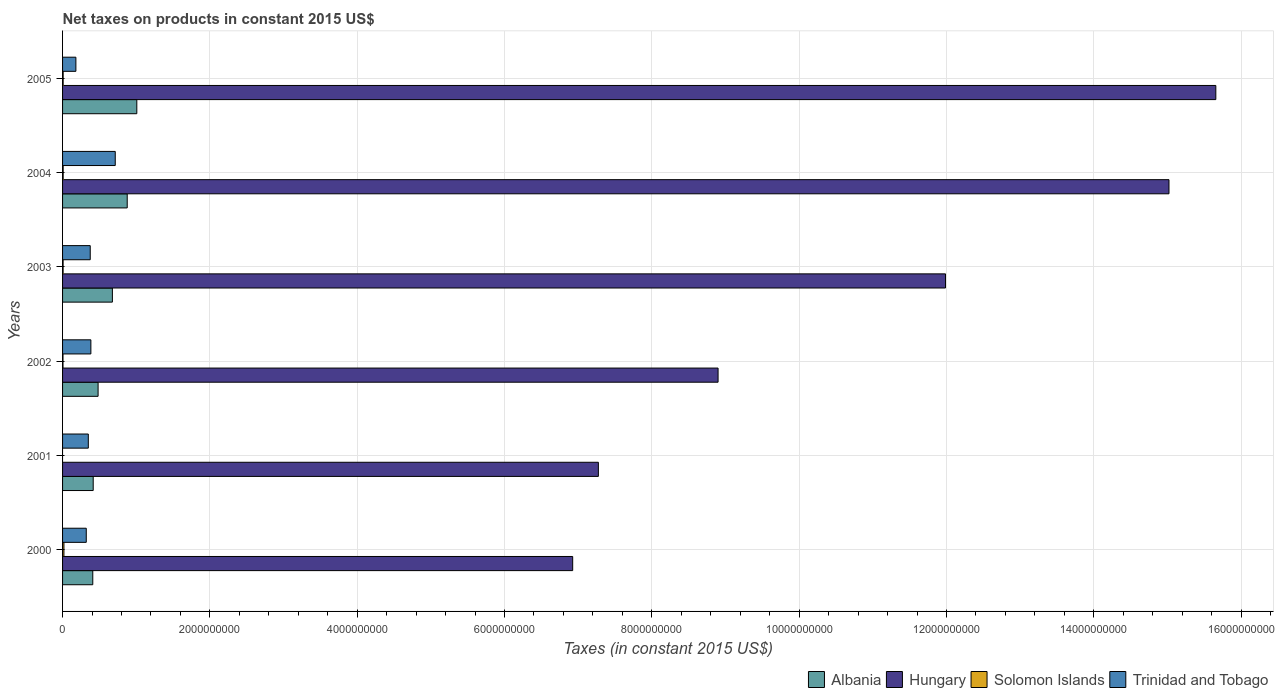Are the number of bars per tick equal to the number of legend labels?
Offer a terse response. No. Are the number of bars on each tick of the Y-axis equal?
Your answer should be very brief. No. How many bars are there on the 2nd tick from the top?
Provide a succinct answer. 4. What is the label of the 2nd group of bars from the top?
Provide a short and direct response. 2004. In how many cases, is the number of bars for a given year not equal to the number of legend labels?
Provide a succinct answer. 1. What is the net taxes on products in Hungary in 2004?
Your response must be concise. 1.50e+1. Across all years, what is the maximum net taxes on products in Hungary?
Your answer should be compact. 1.57e+1. Across all years, what is the minimum net taxes on products in Albania?
Offer a terse response. 4.10e+08. What is the total net taxes on products in Solomon Islands in the graph?
Your answer should be very brief. 4.81e+07. What is the difference between the net taxes on products in Solomon Islands in 2000 and that in 2003?
Your answer should be very brief. 1.11e+07. What is the difference between the net taxes on products in Solomon Islands in 2001 and the net taxes on products in Trinidad and Tobago in 2002?
Make the answer very short. -3.84e+08. What is the average net taxes on products in Trinidad and Tobago per year?
Keep it short and to the point. 3.88e+08. In the year 2004, what is the difference between the net taxes on products in Hungary and net taxes on products in Solomon Islands?
Provide a short and direct response. 1.50e+1. What is the ratio of the net taxes on products in Hungary in 2000 to that in 2001?
Keep it short and to the point. 0.95. Is the net taxes on products in Albania in 2000 less than that in 2002?
Provide a succinct answer. Yes. What is the difference between the highest and the second highest net taxes on products in Solomon Islands?
Keep it short and to the point. 1.04e+07. What is the difference between the highest and the lowest net taxes on products in Trinidad and Tobago?
Your response must be concise. 5.34e+08. In how many years, is the net taxes on products in Solomon Islands greater than the average net taxes on products in Solomon Islands taken over all years?
Make the answer very short. 2. Is it the case that in every year, the sum of the net taxes on products in Albania and net taxes on products in Trinidad and Tobago is greater than the sum of net taxes on products in Solomon Islands and net taxes on products in Hungary?
Keep it short and to the point. Yes. How many bars are there?
Give a very brief answer. 23. What is the difference between two consecutive major ticks on the X-axis?
Your response must be concise. 2.00e+09. Are the values on the major ticks of X-axis written in scientific E-notation?
Give a very brief answer. No. Does the graph contain any zero values?
Provide a succinct answer. Yes. Does the graph contain grids?
Offer a terse response. Yes. How are the legend labels stacked?
Your response must be concise. Horizontal. What is the title of the graph?
Your response must be concise. Net taxes on products in constant 2015 US$. Does "France" appear as one of the legend labels in the graph?
Provide a succinct answer. No. What is the label or title of the X-axis?
Make the answer very short. Taxes (in constant 2015 US$). What is the Taxes (in constant 2015 US$) of Albania in 2000?
Provide a succinct answer. 4.10e+08. What is the Taxes (in constant 2015 US$) of Hungary in 2000?
Give a very brief answer. 6.93e+09. What is the Taxes (in constant 2015 US$) of Solomon Islands in 2000?
Provide a short and direct response. 1.86e+07. What is the Taxes (in constant 2015 US$) in Trinidad and Tobago in 2000?
Give a very brief answer. 3.22e+08. What is the Taxes (in constant 2015 US$) in Albania in 2001?
Ensure brevity in your answer.  4.16e+08. What is the Taxes (in constant 2015 US$) of Hungary in 2001?
Provide a short and direct response. 7.27e+09. What is the Taxes (in constant 2015 US$) in Solomon Islands in 2001?
Give a very brief answer. 0. What is the Taxes (in constant 2015 US$) in Trinidad and Tobago in 2001?
Make the answer very short. 3.50e+08. What is the Taxes (in constant 2015 US$) of Albania in 2002?
Offer a terse response. 4.82e+08. What is the Taxes (in constant 2015 US$) in Hungary in 2002?
Offer a terse response. 8.90e+09. What is the Taxes (in constant 2015 US$) of Solomon Islands in 2002?
Your answer should be compact. 5.98e+06. What is the Taxes (in constant 2015 US$) in Trinidad and Tobago in 2002?
Your answer should be very brief. 3.84e+08. What is the Taxes (in constant 2015 US$) of Albania in 2003?
Offer a very short reply. 6.76e+08. What is the Taxes (in constant 2015 US$) of Hungary in 2003?
Keep it short and to the point. 1.20e+1. What is the Taxes (in constant 2015 US$) of Solomon Islands in 2003?
Keep it short and to the point. 7.43e+06. What is the Taxes (in constant 2015 US$) in Trinidad and Tobago in 2003?
Your answer should be compact. 3.76e+08. What is the Taxes (in constant 2015 US$) of Albania in 2004?
Provide a short and direct response. 8.78e+08. What is the Taxes (in constant 2015 US$) of Hungary in 2004?
Ensure brevity in your answer.  1.50e+1. What is the Taxes (in constant 2015 US$) of Solomon Islands in 2004?
Your answer should be very brief. 8.16e+06. What is the Taxes (in constant 2015 US$) of Trinidad and Tobago in 2004?
Ensure brevity in your answer.  7.15e+08. What is the Taxes (in constant 2015 US$) in Albania in 2005?
Ensure brevity in your answer.  1.01e+09. What is the Taxes (in constant 2015 US$) in Hungary in 2005?
Your response must be concise. 1.57e+1. What is the Taxes (in constant 2015 US$) in Solomon Islands in 2005?
Offer a terse response. 8.01e+06. What is the Taxes (in constant 2015 US$) of Trinidad and Tobago in 2005?
Make the answer very short. 1.81e+08. Across all years, what is the maximum Taxes (in constant 2015 US$) in Albania?
Your answer should be compact. 1.01e+09. Across all years, what is the maximum Taxes (in constant 2015 US$) of Hungary?
Your answer should be compact. 1.57e+1. Across all years, what is the maximum Taxes (in constant 2015 US$) of Solomon Islands?
Ensure brevity in your answer.  1.86e+07. Across all years, what is the maximum Taxes (in constant 2015 US$) of Trinidad and Tobago?
Offer a very short reply. 7.15e+08. Across all years, what is the minimum Taxes (in constant 2015 US$) of Albania?
Provide a short and direct response. 4.10e+08. Across all years, what is the minimum Taxes (in constant 2015 US$) of Hungary?
Give a very brief answer. 6.93e+09. Across all years, what is the minimum Taxes (in constant 2015 US$) of Trinidad and Tobago?
Make the answer very short. 1.81e+08. What is the total Taxes (in constant 2015 US$) in Albania in the graph?
Make the answer very short. 3.87e+09. What is the total Taxes (in constant 2015 US$) of Hungary in the graph?
Offer a very short reply. 6.58e+1. What is the total Taxes (in constant 2015 US$) of Solomon Islands in the graph?
Offer a terse response. 4.81e+07. What is the total Taxes (in constant 2015 US$) of Trinidad and Tobago in the graph?
Offer a very short reply. 2.33e+09. What is the difference between the Taxes (in constant 2015 US$) in Albania in 2000 and that in 2001?
Offer a terse response. -5.75e+06. What is the difference between the Taxes (in constant 2015 US$) of Hungary in 2000 and that in 2001?
Provide a succinct answer. -3.49e+08. What is the difference between the Taxes (in constant 2015 US$) of Trinidad and Tobago in 2000 and that in 2001?
Your answer should be compact. -2.77e+07. What is the difference between the Taxes (in constant 2015 US$) of Albania in 2000 and that in 2002?
Make the answer very short. -7.21e+07. What is the difference between the Taxes (in constant 2015 US$) in Hungary in 2000 and that in 2002?
Your answer should be compact. -1.97e+09. What is the difference between the Taxes (in constant 2015 US$) of Solomon Islands in 2000 and that in 2002?
Provide a succinct answer. 1.26e+07. What is the difference between the Taxes (in constant 2015 US$) of Trinidad and Tobago in 2000 and that in 2002?
Ensure brevity in your answer.  -6.24e+07. What is the difference between the Taxes (in constant 2015 US$) of Albania in 2000 and that in 2003?
Keep it short and to the point. -2.66e+08. What is the difference between the Taxes (in constant 2015 US$) in Hungary in 2000 and that in 2003?
Make the answer very short. -5.06e+09. What is the difference between the Taxes (in constant 2015 US$) of Solomon Islands in 2000 and that in 2003?
Offer a terse response. 1.11e+07. What is the difference between the Taxes (in constant 2015 US$) in Trinidad and Tobago in 2000 and that in 2003?
Provide a succinct answer. -5.38e+07. What is the difference between the Taxes (in constant 2015 US$) in Albania in 2000 and that in 2004?
Give a very brief answer. -4.68e+08. What is the difference between the Taxes (in constant 2015 US$) in Hungary in 2000 and that in 2004?
Your answer should be very brief. -8.10e+09. What is the difference between the Taxes (in constant 2015 US$) of Solomon Islands in 2000 and that in 2004?
Offer a very short reply. 1.04e+07. What is the difference between the Taxes (in constant 2015 US$) in Trinidad and Tobago in 2000 and that in 2004?
Offer a terse response. -3.93e+08. What is the difference between the Taxes (in constant 2015 US$) in Albania in 2000 and that in 2005?
Give a very brief answer. -5.98e+08. What is the difference between the Taxes (in constant 2015 US$) in Hungary in 2000 and that in 2005?
Your answer should be compact. -8.73e+09. What is the difference between the Taxes (in constant 2015 US$) of Solomon Islands in 2000 and that in 2005?
Provide a succinct answer. 1.05e+07. What is the difference between the Taxes (in constant 2015 US$) of Trinidad and Tobago in 2000 and that in 2005?
Provide a short and direct response. 1.41e+08. What is the difference between the Taxes (in constant 2015 US$) in Albania in 2001 and that in 2002?
Your answer should be very brief. -6.63e+07. What is the difference between the Taxes (in constant 2015 US$) of Hungary in 2001 and that in 2002?
Make the answer very short. -1.63e+09. What is the difference between the Taxes (in constant 2015 US$) of Trinidad and Tobago in 2001 and that in 2002?
Your answer should be very brief. -3.47e+07. What is the difference between the Taxes (in constant 2015 US$) of Albania in 2001 and that in 2003?
Your answer should be compact. -2.60e+08. What is the difference between the Taxes (in constant 2015 US$) of Hungary in 2001 and that in 2003?
Make the answer very short. -4.71e+09. What is the difference between the Taxes (in constant 2015 US$) of Trinidad and Tobago in 2001 and that in 2003?
Provide a succinct answer. -2.60e+07. What is the difference between the Taxes (in constant 2015 US$) of Albania in 2001 and that in 2004?
Your answer should be compact. -4.62e+08. What is the difference between the Taxes (in constant 2015 US$) in Hungary in 2001 and that in 2004?
Provide a short and direct response. -7.75e+09. What is the difference between the Taxes (in constant 2015 US$) in Trinidad and Tobago in 2001 and that in 2004?
Your response must be concise. -3.66e+08. What is the difference between the Taxes (in constant 2015 US$) of Albania in 2001 and that in 2005?
Your answer should be very brief. -5.92e+08. What is the difference between the Taxes (in constant 2015 US$) of Hungary in 2001 and that in 2005?
Provide a short and direct response. -8.38e+09. What is the difference between the Taxes (in constant 2015 US$) in Trinidad and Tobago in 2001 and that in 2005?
Your answer should be compact. 1.69e+08. What is the difference between the Taxes (in constant 2015 US$) of Albania in 2002 and that in 2003?
Give a very brief answer. -1.94e+08. What is the difference between the Taxes (in constant 2015 US$) of Hungary in 2002 and that in 2003?
Your answer should be compact. -3.09e+09. What is the difference between the Taxes (in constant 2015 US$) in Solomon Islands in 2002 and that in 2003?
Provide a succinct answer. -1.46e+06. What is the difference between the Taxes (in constant 2015 US$) in Trinidad and Tobago in 2002 and that in 2003?
Offer a very short reply. 8.65e+06. What is the difference between the Taxes (in constant 2015 US$) of Albania in 2002 and that in 2004?
Offer a terse response. -3.95e+08. What is the difference between the Taxes (in constant 2015 US$) of Hungary in 2002 and that in 2004?
Make the answer very short. -6.12e+09. What is the difference between the Taxes (in constant 2015 US$) in Solomon Islands in 2002 and that in 2004?
Ensure brevity in your answer.  -2.18e+06. What is the difference between the Taxes (in constant 2015 US$) of Trinidad and Tobago in 2002 and that in 2004?
Offer a terse response. -3.31e+08. What is the difference between the Taxes (in constant 2015 US$) of Albania in 2002 and that in 2005?
Provide a succinct answer. -5.26e+08. What is the difference between the Taxes (in constant 2015 US$) of Hungary in 2002 and that in 2005?
Provide a succinct answer. -6.76e+09. What is the difference between the Taxes (in constant 2015 US$) in Solomon Islands in 2002 and that in 2005?
Provide a short and direct response. -2.03e+06. What is the difference between the Taxes (in constant 2015 US$) of Trinidad and Tobago in 2002 and that in 2005?
Provide a short and direct response. 2.03e+08. What is the difference between the Taxes (in constant 2015 US$) of Albania in 2003 and that in 2004?
Your answer should be compact. -2.01e+08. What is the difference between the Taxes (in constant 2015 US$) in Hungary in 2003 and that in 2004?
Offer a very short reply. -3.03e+09. What is the difference between the Taxes (in constant 2015 US$) in Solomon Islands in 2003 and that in 2004?
Your answer should be very brief. -7.29e+05. What is the difference between the Taxes (in constant 2015 US$) of Trinidad and Tobago in 2003 and that in 2004?
Ensure brevity in your answer.  -3.40e+08. What is the difference between the Taxes (in constant 2015 US$) of Albania in 2003 and that in 2005?
Keep it short and to the point. -3.32e+08. What is the difference between the Taxes (in constant 2015 US$) in Hungary in 2003 and that in 2005?
Provide a short and direct response. -3.67e+09. What is the difference between the Taxes (in constant 2015 US$) in Solomon Islands in 2003 and that in 2005?
Your response must be concise. -5.74e+05. What is the difference between the Taxes (in constant 2015 US$) of Trinidad and Tobago in 2003 and that in 2005?
Your answer should be very brief. 1.95e+08. What is the difference between the Taxes (in constant 2015 US$) in Albania in 2004 and that in 2005?
Your answer should be very brief. -1.30e+08. What is the difference between the Taxes (in constant 2015 US$) of Hungary in 2004 and that in 2005?
Your answer should be compact. -6.36e+08. What is the difference between the Taxes (in constant 2015 US$) in Solomon Islands in 2004 and that in 2005?
Offer a very short reply. 1.55e+05. What is the difference between the Taxes (in constant 2015 US$) of Trinidad and Tobago in 2004 and that in 2005?
Make the answer very short. 5.34e+08. What is the difference between the Taxes (in constant 2015 US$) of Albania in 2000 and the Taxes (in constant 2015 US$) of Hungary in 2001?
Your response must be concise. -6.86e+09. What is the difference between the Taxes (in constant 2015 US$) of Albania in 2000 and the Taxes (in constant 2015 US$) of Trinidad and Tobago in 2001?
Your answer should be very brief. 6.07e+07. What is the difference between the Taxes (in constant 2015 US$) in Hungary in 2000 and the Taxes (in constant 2015 US$) in Trinidad and Tobago in 2001?
Ensure brevity in your answer.  6.58e+09. What is the difference between the Taxes (in constant 2015 US$) in Solomon Islands in 2000 and the Taxes (in constant 2015 US$) in Trinidad and Tobago in 2001?
Offer a very short reply. -3.31e+08. What is the difference between the Taxes (in constant 2015 US$) of Albania in 2000 and the Taxes (in constant 2015 US$) of Hungary in 2002?
Keep it short and to the point. -8.49e+09. What is the difference between the Taxes (in constant 2015 US$) of Albania in 2000 and the Taxes (in constant 2015 US$) of Solomon Islands in 2002?
Provide a short and direct response. 4.04e+08. What is the difference between the Taxes (in constant 2015 US$) of Albania in 2000 and the Taxes (in constant 2015 US$) of Trinidad and Tobago in 2002?
Keep it short and to the point. 2.60e+07. What is the difference between the Taxes (in constant 2015 US$) in Hungary in 2000 and the Taxes (in constant 2015 US$) in Solomon Islands in 2002?
Offer a very short reply. 6.92e+09. What is the difference between the Taxes (in constant 2015 US$) in Hungary in 2000 and the Taxes (in constant 2015 US$) in Trinidad and Tobago in 2002?
Your response must be concise. 6.54e+09. What is the difference between the Taxes (in constant 2015 US$) in Solomon Islands in 2000 and the Taxes (in constant 2015 US$) in Trinidad and Tobago in 2002?
Offer a very short reply. -3.66e+08. What is the difference between the Taxes (in constant 2015 US$) in Albania in 2000 and the Taxes (in constant 2015 US$) in Hungary in 2003?
Keep it short and to the point. -1.16e+1. What is the difference between the Taxes (in constant 2015 US$) of Albania in 2000 and the Taxes (in constant 2015 US$) of Solomon Islands in 2003?
Ensure brevity in your answer.  4.03e+08. What is the difference between the Taxes (in constant 2015 US$) of Albania in 2000 and the Taxes (in constant 2015 US$) of Trinidad and Tobago in 2003?
Give a very brief answer. 3.46e+07. What is the difference between the Taxes (in constant 2015 US$) in Hungary in 2000 and the Taxes (in constant 2015 US$) in Solomon Islands in 2003?
Give a very brief answer. 6.92e+09. What is the difference between the Taxes (in constant 2015 US$) in Hungary in 2000 and the Taxes (in constant 2015 US$) in Trinidad and Tobago in 2003?
Your answer should be compact. 6.55e+09. What is the difference between the Taxes (in constant 2015 US$) of Solomon Islands in 2000 and the Taxes (in constant 2015 US$) of Trinidad and Tobago in 2003?
Your answer should be very brief. -3.57e+08. What is the difference between the Taxes (in constant 2015 US$) of Albania in 2000 and the Taxes (in constant 2015 US$) of Hungary in 2004?
Offer a very short reply. -1.46e+1. What is the difference between the Taxes (in constant 2015 US$) of Albania in 2000 and the Taxes (in constant 2015 US$) of Solomon Islands in 2004?
Your answer should be compact. 4.02e+08. What is the difference between the Taxes (in constant 2015 US$) in Albania in 2000 and the Taxes (in constant 2015 US$) in Trinidad and Tobago in 2004?
Your response must be concise. -3.05e+08. What is the difference between the Taxes (in constant 2015 US$) in Hungary in 2000 and the Taxes (in constant 2015 US$) in Solomon Islands in 2004?
Provide a short and direct response. 6.92e+09. What is the difference between the Taxes (in constant 2015 US$) in Hungary in 2000 and the Taxes (in constant 2015 US$) in Trinidad and Tobago in 2004?
Offer a terse response. 6.21e+09. What is the difference between the Taxes (in constant 2015 US$) of Solomon Islands in 2000 and the Taxes (in constant 2015 US$) of Trinidad and Tobago in 2004?
Your answer should be very brief. -6.97e+08. What is the difference between the Taxes (in constant 2015 US$) in Albania in 2000 and the Taxes (in constant 2015 US$) in Hungary in 2005?
Give a very brief answer. -1.52e+1. What is the difference between the Taxes (in constant 2015 US$) in Albania in 2000 and the Taxes (in constant 2015 US$) in Solomon Islands in 2005?
Your answer should be very brief. 4.02e+08. What is the difference between the Taxes (in constant 2015 US$) in Albania in 2000 and the Taxes (in constant 2015 US$) in Trinidad and Tobago in 2005?
Give a very brief answer. 2.29e+08. What is the difference between the Taxes (in constant 2015 US$) of Hungary in 2000 and the Taxes (in constant 2015 US$) of Solomon Islands in 2005?
Make the answer very short. 6.92e+09. What is the difference between the Taxes (in constant 2015 US$) of Hungary in 2000 and the Taxes (in constant 2015 US$) of Trinidad and Tobago in 2005?
Keep it short and to the point. 6.74e+09. What is the difference between the Taxes (in constant 2015 US$) in Solomon Islands in 2000 and the Taxes (in constant 2015 US$) in Trinidad and Tobago in 2005?
Your response must be concise. -1.62e+08. What is the difference between the Taxes (in constant 2015 US$) in Albania in 2001 and the Taxes (in constant 2015 US$) in Hungary in 2002?
Make the answer very short. -8.48e+09. What is the difference between the Taxes (in constant 2015 US$) in Albania in 2001 and the Taxes (in constant 2015 US$) in Solomon Islands in 2002?
Your response must be concise. 4.10e+08. What is the difference between the Taxes (in constant 2015 US$) in Albania in 2001 and the Taxes (in constant 2015 US$) in Trinidad and Tobago in 2002?
Make the answer very short. 3.17e+07. What is the difference between the Taxes (in constant 2015 US$) of Hungary in 2001 and the Taxes (in constant 2015 US$) of Solomon Islands in 2002?
Your response must be concise. 7.27e+09. What is the difference between the Taxes (in constant 2015 US$) of Hungary in 2001 and the Taxes (in constant 2015 US$) of Trinidad and Tobago in 2002?
Give a very brief answer. 6.89e+09. What is the difference between the Taxes (in constant 2015 US$) of Albania in 2001 and the Taxes (in constant 2015 US$) of Hungary in 2003?
Keep it short and to the point. -1.16e+1. What is the difference between the Taxes (in constant 2015 US$) in Albania in 2001 and the Taxes (in constant 2015 US$) in Solomon Islands in 2003?
Your response must be concise. 4.09e+08. What is the difference between the Taxes (in constant 2015 US$) in Albania in 2001 and the Taxes (in constant 2015 US$) in Trinidad and Tobago in 2003?
Your answer should be very brief. 4.04e+07. What is the difference between the Taxes (in constant 2015 US$) of Hungary in 2001 and the Taxes (in constant 2015 US$) of Solomon Islands in 2003?
Your answer should be compact. 7.27e+09. What is the difference between the Taxes (in constant 2015 US$) in Hungary in 2001 and the Taxes (in constant 2015 US$) in Trinidad and Tobago in 2003?
Provide a succinct answer. 6.90e+09. What is the difference between the Taxes (in constant 2015 US$) in Albania in 2001 and the Taxes (in constant 2015 US$) in Hungary in 2004?
Give a very brief answer. -1.46e+1. What is the difference between the Taxes (in constant 2015 US$) in Albania in 2001 and the Taxes (in constant 2015 US$) in Solomon Islands in 2004?
Give a very brief answer. 4.08e+08. What is the difference between the Taxes (in constant 2015 US$) of Albania in 2001 and the Taxes (in constant 2015 US$) of Trinidad and Tobago in 2004?
Your answer should be very brief. -2.99e+08. What is the difference between the Taxes (in constant 2015 US$) of Hungary in 2001 and the Taxes (in constant 2015 US$) of Solomon Islands in 2004?
Ensure brevity in your answer.  7.27e+09. What is the difference between the Taxes (in constant 2015 US$) of Hungary in 2001 and the Taxes (in constant 2015 US$) of Trinidad and Tobago in 2004?
Offer a terse response. 6.56e+09. What is the difference between the Taxes (in constant 2015 US$) in Albania in 2001 and the Taxes (in constant 2015 US$) in Hungary in 2005?
Provide a short and direct response. -1.52e+1. What is the difference between the Taxes (in constant 2015 US$) in Albania in 2001 and the Taxes (in constant 2015 US$) in Solomon Islands in 2005?
Your answer should be very brief. 4.08e+08. What is the difference between the Taxes (in constant 2015 US$) of Albania in 2001 and the Taxes (in constant 2015 US$) of Trinidad and Tobago in 2005?
Offer a very short reply. 2.35e+08. What is the difference between the Taxes (in constant 2015 US$) of Hungary in 2001 and the Taxes (in constant 2015 US$) of Solomon Islands in 2005?
Provide a short and direct response. 7.27e+09. What is the difference between the Taxes (in constant 2015 US$) in Hungary in 2001 and the Taxes (in constant 2015 US$) in Trinidad and Tobago in 2005?
Give a very brief answer. 7.09e+09. What is the difference between the Taxes (in constant 2015 US$) of Albania in 2002 and the Taxes (in constant 2015 US$) of Hungary in 2003?
Provide a succinct answer. -1.15e+1. What is the difference between the Taxes (in constant 2015 US$) in Albania in 2002 and the Taxes (in constant 2015 US$) in Solomon Islands in 2003?
Your answer should be compact. 4.75e+08. What is the difference between the Taxes (in constant 2015 US$) in Albania in 2002 and the Taxes (in constant 2015 US$) in Trinidad and Tobago in 2003?
Offer a terse response. 1.07e+08. What is the difference between the Taxes (in constant 2015 US$) in Hungary in 2002 and the Taxes (in constant 2015 US$) in Solomon Islands in 2003?
Ensure brevity in your answer.  8.89e+09. What is the difference between the Taxes (in constant 2015 US$) of Hungary in 2002 and the Taxes (in constant 2015 US$) of Trinidad and Tobago in 2003?
Your answer should be very brief. 8.52e+09. What is the difference between the Taxes (in constant 2015 US$) of Solomon Islands in 2002 and the Taxes (in constant 2015 US$) of Trinidad and Tobago in 2003?
Provide a short and direct response. -3.70e+08. What is the difference between the Taxes (in constant 2015 US$) in Albania in 2002 and the Taxes (in constant 2015 US$) in Hungary in 2004?
Ensure brevity in your answer.  -1.45e+1. What is the difference between the Taxes (in constant 2015 US$) in Albania in 2002 and the Taxes (in constant 2015 US$) in Solomon Islands in 2004?
Make the answer very short. 4.74e+08. What is the difference between the Taxes (in constant 2015 US$) of Albania in 2002 and the Taxes (in constant 2015 US$) of Trinidad and Tobago in 2004?
Your answer should be very brief. -2.33e+08. What is the difference between the Taxes (in constant 2015 US$) of Hungary in 2002 and the Taxes (in constant 2015 US$) of Solomon Islands in 2004?
Your response must be concise. 8.89e+09. What is the difference between the Taxes (in constant 2015 US$) of Hungary in 2002 and the Taxes (in constant 2015 US$) of Trinidad and Tobago in 2004?
Keep it short and to the point. 8.18e+09. What is the difference between the Taxes (in constant 2015 US$) of Solomon Islands in 2002 and the Taxes (in constant 2015 US$) of Trinidad and Tobago in 2004?
Offer a terse response. -7.09e+08. What is the difference between the Taxes (in constant 2015 US$) in Albania in 2002 and the Taxes (in constant 2015 US$) in Hungary in 2005?
Your answer should be compact. -1.52e+1. What is the difference between the Taxes (in constant 2015 US$) in Albania in 2002 and the Taxes (in constant 2015 US$) in Solomon Islands in 2005?
Provide a short and direct response. 4.74e+08. What is the difference between the Taxes (in constant 2015 US$) in Albania in 2002 and the Taxes (in constant 2015 US$) in Trinidad and Tobago in 2005?
Ensure brevity in your answer.  3.01e+08. What is the difference between the Taxes (in constant 2015 US$) of Hungary in 2002 and the Taxes (in constant 2015 US$) of Solomon Islands in 2005?
Your answer should be very brief. 8.89e+09. What is the difference between the Taxes (in constant 2015 US$) in Hungary in 2002 and the Taxes (in constant 2015 US$) in Trinidad and Tobago in 2005?
Make the answer very short. 8.72e+09. What is the difference between the Taxes (in constant 2015 US$) in Solomon Islands in 2002 and the Taxes (in constant 2015 US$) in Trinidad and Tobago in 2005?
Your response must be concise. -1.75e+08. What is the difference between the Taxes (in constant 2015 US$) of Albania in 2003 and the Taxes (in constant 2015 US$) of Hungary in 2004?
Offer a terse response. -1.43e+1. What is the difference between the Taxes (in constant 2015 US$) of Albania in 2003 and the Taxes (in constant 2015 US$) of Solomon Islands in 2004?
Ensure brevity in your answer.  6.68e+08. What is the difference between the Taxes (in constant 2015 US$) of Albania in 2003 and the Taxes (in constant 2015 US$) of Trinidad and Tobago in 2004?
Offer a terse response. -3.88e+07. What is the difference between the Taxes (in constant 2015 US$) in Hungary in 2003 and the Taxes (in constant 2015 US$) in Solomon Islands in 2004?
Offer a very short reply. 1.20e+1. What is the difference between the Taxes (in constant 2015 US$) of Hungary in 2003 and the Taxes (in constant 2015 US$) of Trinidad and Tobago in 2004?
Keep it short and to the point. 1.13e+1. What is the difference between the Taxes (in constant 2015 US$) in Solomon Islands in 2003 and the Taxes (in constant 2015 US$) in Trinidad and Tobago in 2004?
Your answer should be compact. -7.08e+08. What is the difference between the Taxes (in constant 2015 US$) of Albania in 2003 and the Taxes (in constant 2015 US$) of Hungary in 2005?
Provide a short and direct response. -1.50e+1. What is the difference between the Taxes (in constant 2015 US$) of Albania in 2003 and the Taxes (in constant 2015 US$) of Solomon Islands in 2005?
Your answer should be very brief. 6.68e+08. What is the difference between the Taxes (in constant 2015 US$) in Albania in 2003 and the Taxes (in constant 2015 US$) in Trinidad and Tobago in 2005?
Offer a very short reply. 4.96e+08. What is the difference between the Taxes (in constant 2015 US$) of Hungary in 2003 and the Taxes (in constant 2015 US$) of Solomon Islands in 2005?
Ensure brevity in your answer.  1.20e+1. What is the difference between the Taxes (in constant 2015 US$) in Hungary in 2003 and the Taxes (in constant 2015 US$) in Trinidad and Tobago in 2005?
Your answer should be compact. 1.18e+1. What is the difference between the Taxes (in constant 2015 US$) in Solomon Islands in 2003 and the Taxes (in constant 2015 US$) in Trinidad and Tobago in 2005?
Ensure brevity in your answer.  -1.73e+08. What is the difference between the Taxes (in constant 2015 US$) of Albania in 2004 and the Taxes (in constant 2015 US$) of Hungary in 2005?
Your answer should be very brief. -1.48e+1. What is the difference between the Taxes (in constant 2015 US$) in Albania in 2004 and the Taxes (in constant 2015 US$) in Solomon Islands in 2005?
Provide a short and direct response. 8.70e+08. What is the difference between the Taxes (in constant 2015 US$) of Albania in 2004 and the Taxes (in constant 2015 US$) of Trinidad and Tobago in 2005?
Your answer should be very brief. 6.97e+08. What is the difference between the Taxes (in constant 2015 US$) in Hungary in 2004 and the Taxes (in constant 2015 US$) in Solomon Islands in 2005?
Provide a succinct answer. 1.50e+1. What is the difference between the Taxes (in constant 2015 US$) of Hungary in 2004 and the Taxes (in constant 2015 US$) of Trinidad and Tobago in 2005?
Ensure brevity in your answer.  1.48e+1. What is the difference between the Taxes (in constant 2015 US$) in Solomon Islands in 2004 and the Taxes (in constant 2015 US$) in Trinidad and Tobago in 2005?
Provide a short and direct response. -1.73e+08. What is the average Taxes (in constant 2015 US$) of Albania per year?
Offer a very short reply. 6.45e+08. What is the average Taxes (in constant 2015 US$) in Hungary per year?
Your answer should be very brief. 1.10e+1. What is the average Taxes (in constant 2015 US$) of Solomon Islands per year?
Give a very brief answer. 8.02e+06. What is the average Taxes (in constant 2015 US$) of Trinidad and Tobago per year?
Keep it short and to the point. 3.88e+08. In the year 2000, what is the difference between the Taxes (in constant 2015 US$) of Albania and Taxes (in constant 2015 US$) of Hungary?
Provide a succinct answer. -6.52e+09. In the year 2000, what is the difference between the Taxes (in constant 2015 US$) in Albania and Taxes (in constant 2015 US$) in Solomon Islands?
Offer a very short reply. 3.92e+08. In the year 2000, what is the difference between the Taxes (in constant 2015 US$) in Albania and Taxes (in constant 2015 US$) in Trinidad and Tobago?
Offer a terse response. 8.84e+07. In the year 2000, what is the difference between the Taxes (in constant 2015 US$) in Hungary and Taxes (in constant 2015 US$) in Solomon Islands?
Your answer should be very brief. 6.91e+09. In the year 2000, what is the difference between the Taxes (in constant 2015 US$) in Hungary and Taxes (in constant 2015 US$) in Trinidad and Tobago?
Make the answer very short. 6.60e+09. In the year 2000, what is the difference between the Taxes (in constant 2015 US$) in Solomon Islands and Taxes (in constant 2015 US$) in Trinidad and Tobago?
Your answer should be compact. -3.03e+08. In the year 2001, what is the difference between the Taxes (in constant 2015 US$) in Albania and Taxes (in constant 2015 US$) in Hungary?
Provide a succinct answer. -6.86e+09. In the year 2001, what is the difference between the Taxes (in constant 2015 US$) of Albania and Taxes (in constant 2015 US$) of Trinidad and Tobago?
Your answer should be compact. 6.64e+07. In the year 2001, what is the difference between the Taxes (in constant 2015 US$) in Hungary and Taxes (in constant 2015 US$) in Trinidad and Tobago?
Offer a very short reply. 6.92e+09. In the year 2002, what is the difference between the Taxes (in constant 2015 US$) of Albania and Taxes (in constant 2015 US$) of Hungary?
Your response must be concise. -8.42e+09. In the year 2002, what is the difference between the Taxes (in constant 2015 US$) in Albania and Taxes (in constant 2015 US$) in Solomon Islands?
Give a very brief answer. 4.76e+08. In the year 2002, what is the difference between the Taxes (in constant 2015 US$) of Albania and Taxes (in constant 2015 US$) of Trinidad and Tobago?
Provide a succinct answer. 9.81e+07. In the year 2002, what is the difference between the Taxes (in constant 2015 US$) of Hungary and Taxes (in constant 2015 US$) of Solomon Islands?
Your response must be concise. 8.89e+09. In the year 2002, what is the difference between the Taxes (in constant 2015 US$) of Hungary and Taxes (in constant 2015 US$) of Trinidad and Tobago?
Give a very brief answer. 8.51e+09. In the year 2002, what is the difference between the Taxes (in constant 2015 US$) of Solomon Islands and Taxes (in constant 2015 US$) of Trinidad and Tobago?
Keep it short and to the point. -3.78e+08. In the year 2003, what is the difference between the Taxes (in constant 2015 US$) of Albania and Taxes (in constant 2015 US$) of Hungary?
Give a very brief answer. -1.13e+1. In the year 2003, what is the difference between the Taxes (in constant 2015 US$) in Albania and Taxes (in constant 2015 US$) in Solomon Islands?
Offer a terse response. 6.69e+08. In the year 2003, what is the difference between the Taxes (in constant 2015 US$) of Albania and Taxes (in constant 2015 US$) of Trinidad and Tobago?
Your answer should be compact. 3.01e+08. In the year 2003, what is the difference between the Taxes (in constant 2015 US$) of Hungary and Taxes (in constant 2015 US$) of Solomon Islands?
Your answer should be very brief. 1.20e+1. In the year 2003, what is the difference between the Taxes (in constant 2015 US$) of Hungary and Taxes (in constant 2015 US$) of Trinidad and Tobago?
Provide a short and direct response. 1.16e+1. In the year 2003, what is the difference between the Taxes (in constant 2015 US$) of Solomon Islands and Taxes (in constant 2015 US$) of Trinidad and Tobago?
Your response must be concise. -3.68e+08. In the year 2004, what is the difference between the Taxes (in constant 2015 US$) in Albania and Taxes (in constant 2015 US$) in Hungary?
Your response must be concise. -1.41e+1. In the year 2004, what is the difference between the Taxes (in constant 2015 US$) in Albania and Taxes (in constant 2015 US$) in Solomon Islands?
Your answer should be very brief. 8.70e+08. In the year 2004, what is the difference between the Taxes (in constant 2015 US$) in Albania and Taxes (in constant 2015 US$) in Trinidad and Tobago?
Your answer should be very brief. 1.62e+08. In the year 2004, what is the difference between the Taxes (in constant 2015 US$) in Hungary and Taxes (in constant 2015 US$) in Solomon Islands?
Provide a succinct answer. 1.50e+1. In the year 2004, what is the difference between the Taxes (in constant 2015 US$) in Hungary and Taxes (in constant 2015 US$) in Trinidad and Tobago?
Your response must be concise. 1.43e+1. In the year 2004, what is the difference between the Taxes (in constant 2015 US$) in Solomon Islands and Taxes (in constant 2015 US$) in Trinidad and Tobago?
Offer a terse response. -7.07e+08. In the year 2005, what is the difference between the Taxes (in constant 2015 US$) of Albania and Taxes (in constant 2015 US$) of Hungary?
Your response must be concise. -1.46e+1. In the year 2005, what is the difference between the Taxes (in constant 2015 US$) of Albania and Taxes (in constant 2015 US$) of Solomon Islands?
Your answer should be compact. 1.00e+09. In the year 2005, what is the difference between the Taxes (in constant 2015 US$) of Albania and Taxes (in constant 2015 US$) of Trinidad and Tobago?
Keep it short and to the point. 8.27e+08. In the year 2005, what is the difference between the Taxes (in constant 2015 US$) of Hungary and Taxes (in constant 2015 US$) of Solomon Islands?
Keep it short and to the point. 1.56e+1. In the year 2005, what is the difference between the Taxes (in constant 2015 US$) of Hungary and Taxes (in constant 2015 US$) of Trinidad and Tobago?
Your answer should be compact. 1.55e+1. In the year 2005, what is the difference between the Taxes (in constant 2015 US$) of Solomon Islands and Taxes (in constant 2015 US$) of Trinidad and Tobago?
Ensure brevity in your answer.  -1.73e+08. What is the ratio of the Taxes (in constant 2015 US$) in Albania in 2000 to that in 2001?
Offer a terse response. 0.99. What is the ratio of the Taxes (in constant 2015 US$) of Hungary in 2000 to that in 2001?
Offer a very short reply. 0.95. What is the ratio of the Taxes (in constant 2015 US$) in Trinidad and Tobago in 2000 to that in 2001?
Your answer should be very brief. 0.92. What is the ratio of the Taxes (in constant 2015 US$) of Albania in 2000 to that in 2002?
Your answer should be compact. 0.85. What is the ratio of the Taxes (in constant 2015 US$) in Hungary in 2000 to that in 2002?
Provide a short and direct response. 0.78. What is the ratio of the Taxes (in constant 2015 US$) in Solomon Islands in 2000 to that in 2002?
Your response must be concise. 3.1. What is the ratio of the Taxes (in constant 2015 US$) in Trinidad and Tobago in 2000 to that in 2002?
Give a very brief answer. 0.84. What is the ratio of the Taxes (in constant 2015 US$) in Albania in 2000 to that in 2003?
Keep it short and to the point. 0.61. What is the ratio of the Taxes (in constant 2015 US$) in Hungary in 2000 to that in 2003?
Keep it short and to the point. 0.58. What is the ratio of the Taxes (in constant 2015 US$) in Solomon Islands in 2000 to that in 2003?
Give a very brief answer. 2.5. What is the ratio of the Taxes (in constant 2015 US$) of Trinidad and Tobago in 2000 to that in 2003?
Your answer should be very brief. 0.86. What is the ratio of the Taxes (in constant 2015 US$) in Albania in 2000 to that in 2004?
Give a very brief answer. 0.47. What is the ratio of the Taxes (in constant 2015 US$) of Hungary in 2000 to that in 2004?
Make the answer very short. 0.46. What is the ratio of the Taxes (in constant 2015 US$) in Solomon Islands in 2000 to that in 2004?
Provide a short and direct response. 2.27. What is the ratio of the Taxes (in constant 2015 US$) of Trinidad and Tobago in 2000 to that in 2004?
Give a very brief answer. 0.45. What is the ratio of the Taxes (in constant 2015 US$) of Albania in 2000 to that in 2005?
Your response must be concise. 0.41. What is the ratio of the Taxes (in constant 2015 US$) of Hungary in 2000 to that in 2005?
Offer a terse response. 0.44. What is the ratio of the Taxes (in constant 2015 US$) in Solomon Islands in 2000 to that in 2005?
Provide a succinct answer. 2.32. What is the ratio of the Taxes (in constant 2015 US$) in Trinidad and Tobago in 2000 to that in 2005?
Offer a terse response. 1.78. What is the ratio of the Taxes (in constant 2015 US$) in Albania in 2001 to that in 2002?
Keep it short and to the point. 0.86. What is the ratio of the Taxes (in constant 2015 US$) of Hungary in 2001 to that in 2002?
Keep it short and to the point. 0.82. What is the ratio of the Taxes (in constant 2015 US$) in Trinidad and Tobago in 2001 to that in 2002?
Your answer should be very brief. 0.91. What is the ratio of the Taxes (in constant 2015 US$) of Albania in 2001 to that in 2003?
Provide a short and direct response. 0.61. What is the ratio of the Taxes (in constant 2015 US$) of Hungary in 2001 to that in 2003?
Provide a succinct answer. 0.61. What is the ratio of the Taxes (in constant 2015 US$) of Trinidad and Tobago in 2001 to that in 2003?
Your answer should be compact. 0.93. What is the ratio of the Taxes (in constant 2015 US$) in Albania in 2001 to that in 2004?
Your response must be concise. 0.47. What is the ratio of the Taxes (in constant 2015 US$) in Hungary in 2001 to that in 2004?
Ensure brevity in your answer.  0.48. What is the ratio of the Taxes (in constant 2015 US$) in Trinidad and Tobago in 2001 to that in 2004?
Your response must be concise. 0.49. What is the ratio of the Taxes (in constant 2015 US$) in Albania in 2001 to that in 2005?
Your response must be concise. 0.41. What is the ratio of the Taxes (in constant 2015 US$) in Hungary in 2001 to that in 2005?
Offer a terse response. 0.46. What is the ratio of the Taxes (in constant 2015 US$) of Trinidad and Tobago in 2001 to that in 2005?
Offer a terse response. 1.93. What is the ratio of the Taxes (in constant 2015 US$) in Albania in 2002 to that in 2003?
Your answer should be very brief. 0.71. What is the ratio of the Taxes (in constant 2015 US$) of Hungary in 2002 to that in 2003?
Your response must be concise. 0.74. What is the ratio of the Taxes (in constant 2015 US$) in Solomon Islands in 2002 to that in 2003?
Your response must be concise. 0.8. What is the ratio of the Taxes (in constant 2015 US$) in Trinidad and Tobago in 2002 to that in 2003?
Your response must be concise. 1.02. What is the ratio of the Taxes (in constant 2015 US$) of Albania in 2002 to that in 2004?
Provide a succinct answer. 0.55. What is the ratio of the Taxes (in constant 2015 US$) of Hungary in 2002 to that in 2004?
Give a very brief answer. 0.59. What is the ratio of the Taxes (in constant 2015 US$) of Solomon Islands in 2002 to that in 2004?
Your response must be concise. 0.73. What is the ratio of the Taxes (in constant 2015 US$) of Trinidad and Tobago in 2002 to that in 2004?
Keep it short and to the point. 0.54. What is the ratio of the Taxes (in constant 2015 US$) of Albania in 2002 to that in 2005?
Your answer should be compact. 0.48. What is the ratio of the Taxes (in constant 2015 US$) in Hungary in 2002 to that in 2005?
Offer a terse response. 0.57. What is the ratio of the Taxes (in constant 2015 US$) of Solomon Islands in 2002 to that in 2005?
Make the answer very short. 0.75. What is the ratio of the Taxes (in constant 2015 US$) of Trinidad and Tobago in 2002 to that in 2005?
Your answer should be compact. 2.13. What is the ratio of the Taxes (in constant 2015 US$) of Albania in 2003 to that in 2004?
Give a very brief answer. 0.77. What is the ratio of the Taxes (in constant 2015 US$) of Hungary in 2003 to that in 2004?
Your answer should be very brief. 0.8. What is the ratio of the Taxes (in constant 2015 US$) in Solomon Islands in 2003 to that in 2004?
Your answer should be very brief. 0.91. What is the ratio of the Taxes (in constant 2015 US$) in Trinidad and Tobago in 2003 to that in 2004?
Your answer should be very brief. 0.53. What is the ratio of the Taxes (in constant 2015 US$) in Albania in 2003 to that in 2005?
Your response must be concise. 0.67. What is the ratio of the Taxes (in constant 2015 US$) of Hungary in 2003 to that in 2005?
Provide a short and direct response. 0.77. What is the ratio of the Taxes (in constant 2015 US$) of Solomon Islands in 2003 to that in 2005?
Make the answer very short. 0.93. What is the ratio of the Taxes (in constant 2015 US$) of Trinidad and Tobago in 2003 to that in 2005?
Ensure brevity in your answer.  2.08. What is the ratio of the Taxes (in constant 2015 US$) in Albania in 2004 to that in 2005?
Your answer should be very brief. 0.87. What is the ratio of the Taxes (in constant 2015 US$) of Hungary in 2004 to that in 2005?
Your response must be concise. 0.96. What is the ratio of the Taxes (in constant 2015 US$) in Solomon Islands in 2004 to that in 2005?
Give a very brief answer. 1.02. What is the ratio of the Taxes (in constant 2015 US$) in Trinidad and Tobago in 2004 to that in 2005?
Your response must be concise. 3.96. What is the difference between the highest and the second highest Taxes (in constant 2015 US$) of Albania?
Provide a succinct answer. 1.30e+08. What is the difference between the highest and the second highest Taxes (in constant 2015 US$) of Hungary?
Offer a very short reply. 6.36e+08. What is the difference between the highest and the second highest Taxes (in constant 2015 US$) in Solomon Islands?
Your answer should be very brief. 1.04e+07. What is the difference between the highest and the second highest Taxes (in constant 2015 US$) of Trinidad and Tobago?
Provide a short and direct response. 3.31e+08. What is the difference between the highest and the lowest Taxes (in constant 2015 US$) in Albania?
Your answer should be compact. 5.98e+08. What is the difference between the highest and the lowest Taxes (in constant 2015 US$) of Hungary?
Your answer should be compact. 8.73e+09. What is the difference between the highest and the lowest Taxes (in constant 2015 US$) of Solomon Islands?
Your response must be concise. 1.86e+07. What is the difference between the highest and the lowest Taxes (in constant 2015 US$) of Trinidad and Tobago?
Your answer should be compact. 5.34e+08. 